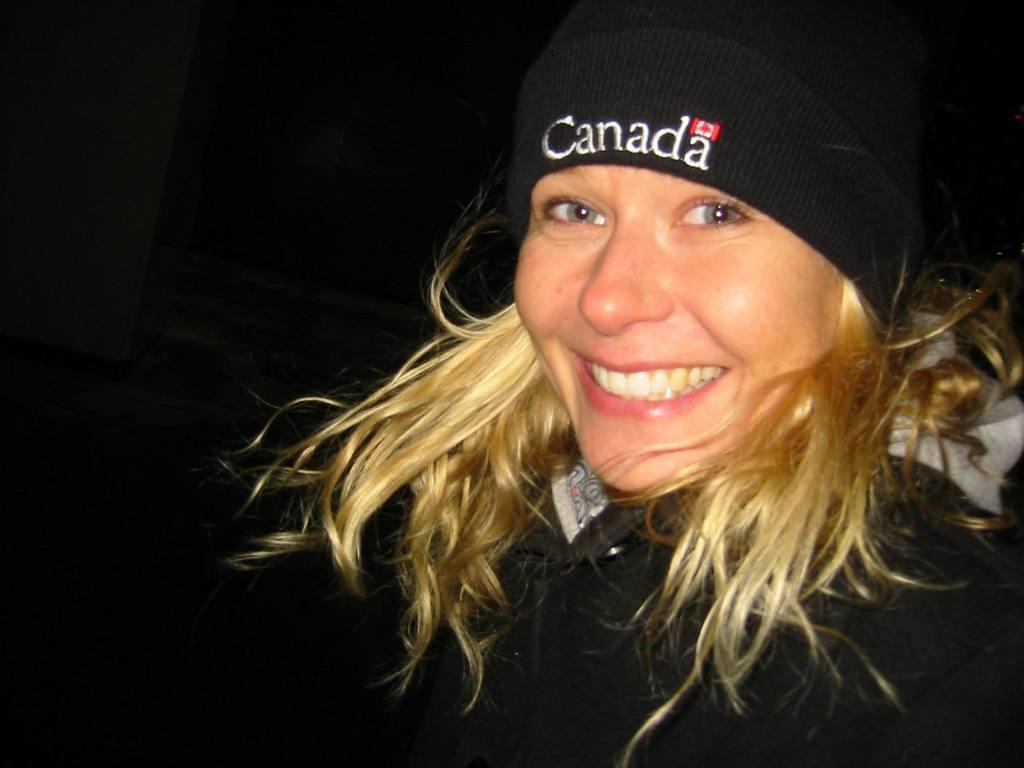What is the main subject of the image? There is a person in the image. What is the person wearing? The person is wearing a black jacket and a cap. What is the person's facial expression? The person is smiling. How would you describe the background of the image? The background of the image is dark. Reasoning: Let' Let's think step by step in order to produce the conversation. We start by identifying the main subject of the image, which is the person. Then, we describe the person's clothing and facial expression, as well as the background of the image. Each question is designed to elicit a specific detail about the image that is known from the provided facts. Absurd Question/Answer: What type of letter is the person holding in the image? There is no letter present in the image. Can you see any toads in the image? There are no toads present in the image. What type of dirt can be seen on the person's shoes in the image? There is no dirt visible on the person's shoes in the image. Can you see any toads in the image? There are no toads present in the image. 